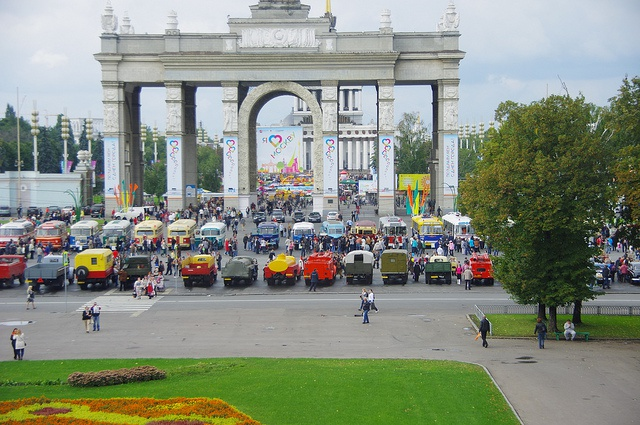Describe the objects in this image and their specific colors. I can see car in lightgray, darkgray, gray, black, and navy tones, people in lightgray, gray, darkgray, black, and navy tones, truck in lightgray, black, gold, olive, and brown tones, bus in lightgray, gray, darkgray, and darkgreen tones, and truck in lightgray, gray, black, and darkgray tones in this image. 